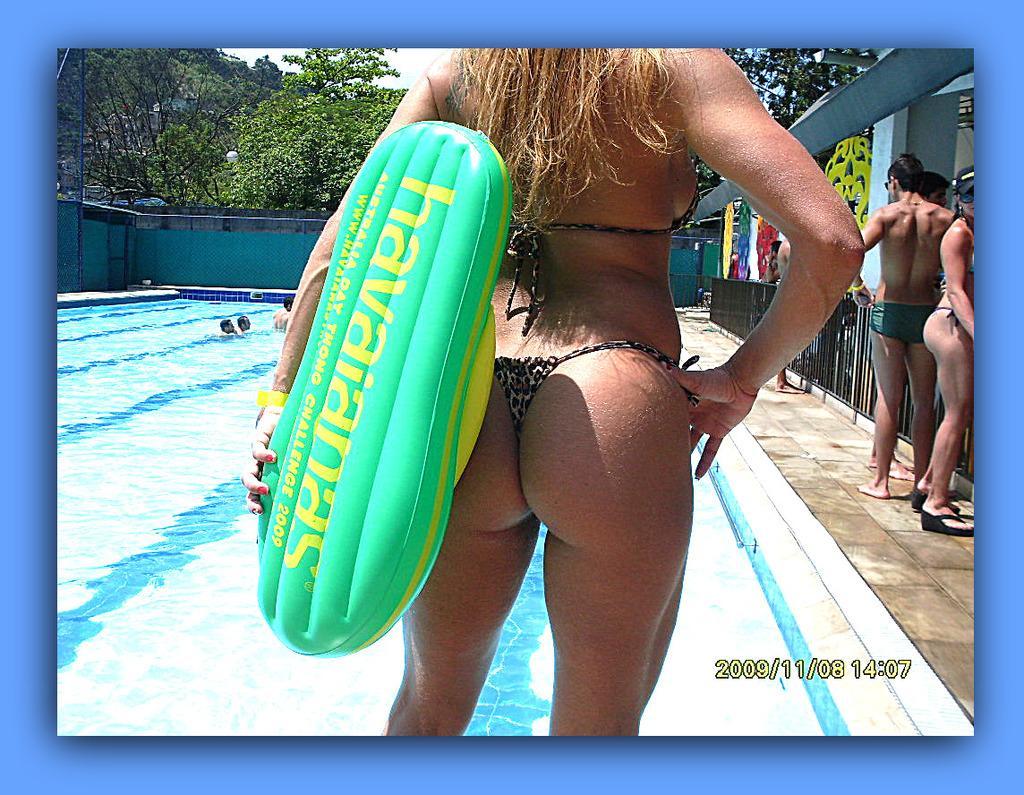How would you summarize this image in a sentence or two? In the foreground of this image, there is a woman holding an inflatable object. In the background, there is a swimming pool in which there are few people. On the right, there are few people standing on the path. We can also see a railing, wall and trees in the background. 